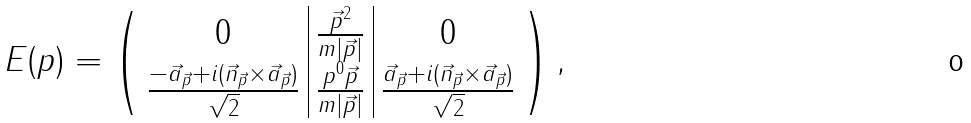<formula> <loc_0><loc_0><loc_500><loc_500>E ( p ) = \left ( \begin{array} { c | c | c } 0 & \frac { \vec { p } ^ { 2 } } { m | \vec { p } | } & 0 \\ \frac { - \vec { a } _ { \vec { p } } + i ( \vec { n } _ { \vec { p } } \times \vec { a } _ { \vec { p } } ) } { \sqrt { 2 } } & \frac { p ^ { 0 } \vec { p } } { m | \vec { p } | } & \frac { \vec { a } _ { \vec { p } } + i ( \vec { n } _ { \vec { p } } \times \vec { a } _ { \vec { p } } ) } { \sqrt { 2 } } \end{array} \right ) ,</formula> 